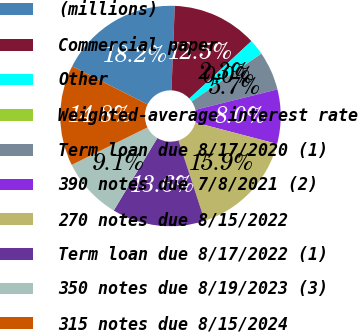Convert chart to OTSL. <chart><loc_0><loc_0><loc_500><loc_500><pie_chart><fcel>(millions)<fcel>Commercial paper<fcel>Other<fcel>Weighted-average interest rate<fcel>Term loan due 8/17/2020 (1)<fcel>390 notes due 7/8/2021 (2)<fcel>270 notes due 8/15/2022<fcel>Term loan due 8/17/2022 (1)<fcel>350 notes due 8/19/2023 (3)<fcel>315 notes due 8/15/2024<nl><fcel>18.17%<fcel>12.5%<fcel>2.29%<fcel>0.02%<fcel>5.69%<fcel>7.96%<fcel>15.9%<fcel>13.63%<fcel>9.09%<fcel>14.76%<nl></chart> 